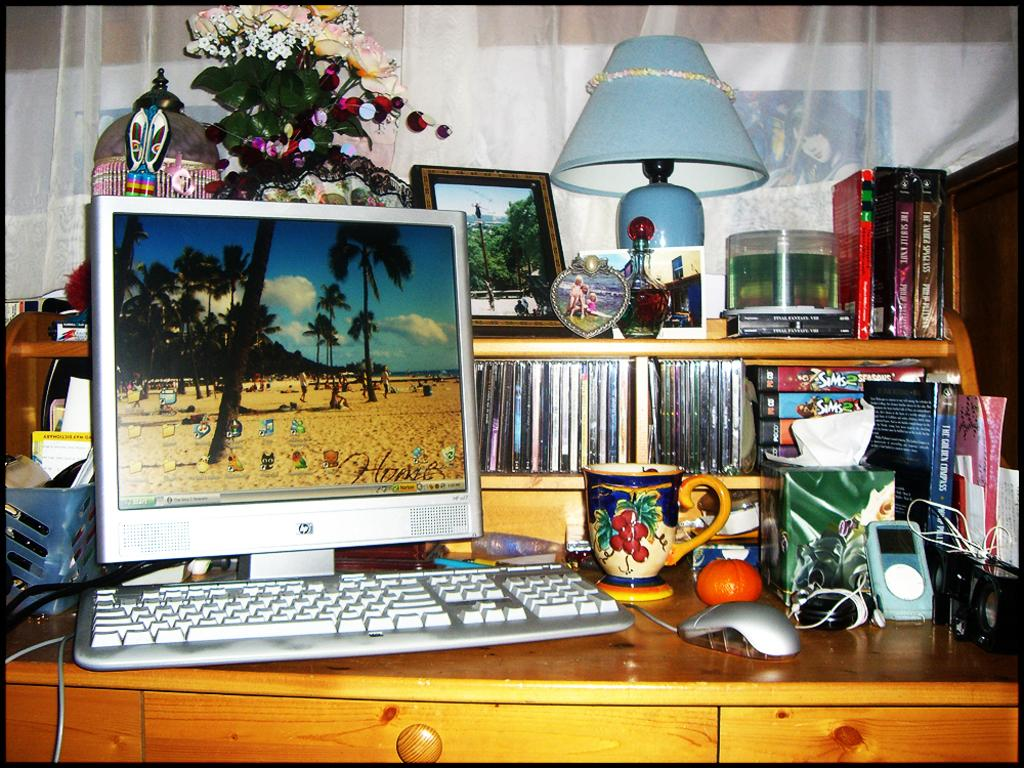What electronic device is on the table in the image? There is a laptop on the table in the image. What is used to hold writing instruments on the table? There is a pen-holder on the table. What is used for decoration or greenery on the table? There is a flower pot on the table. What is used for illumination on the table? There is a lamp on the table. What is used for displaying a picture on the table? There is a frame on the table. What is used for storing CDs on the table? There are CDs on the table. What is used for holding a beverage on the table? There is a cup on the table. What is used for controlling the laptop on the table? There is a mouse on the table. What can be seen in the background of the image? There is a curtain in the background. How many chickens are visible on the table in the image? There are no chickens present on the table in the image. What part of the table is used for attempting to balance the laptop? The table is a solid surface and does not have a specific part for attempting to balance the laptop; the laptop is simply placed on the table. 